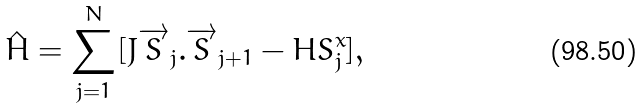<formula> <loc_0><loc_0><loc_500><loc_500>\hat { H } = \sum _ { j = 1 } ^ { N } [ J \overrightarrow { S } _ { j } . \overrightarrow { S } _ { j + 1 } - H S _ { j } ^ { x } ] ,</formula> 